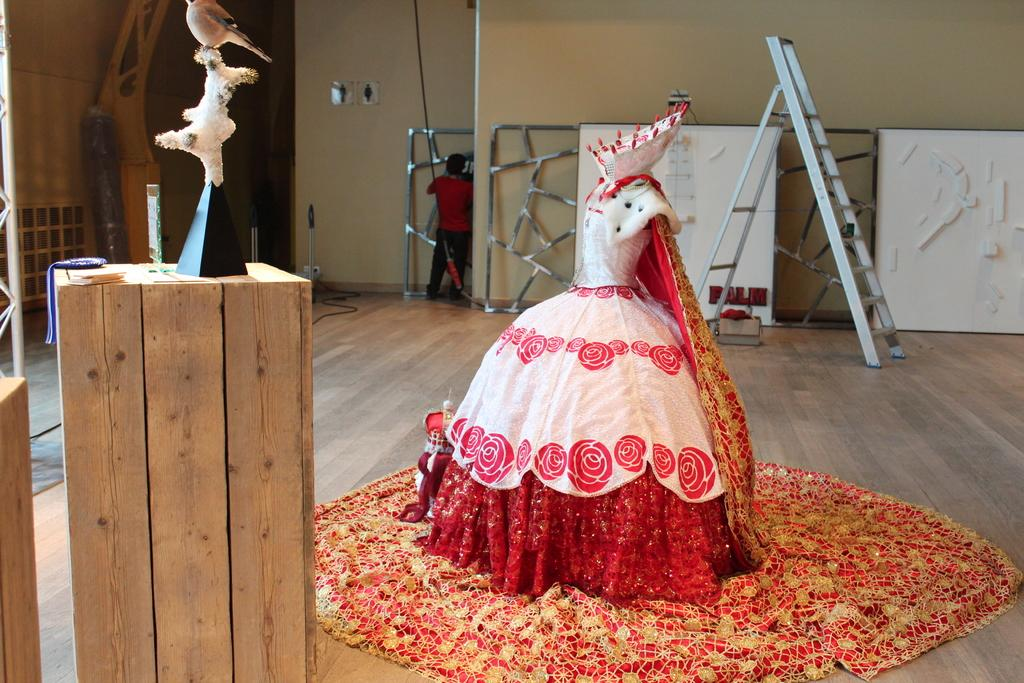What is present in the image that serves as a background? There is a wall in the image that serves as a background. Who or what can be seen in front of the wall? There is a man standing in the image. What object is visible in the image that can be used for climbing? There is a ladder in the image that can be used for climbing. What object is present in the image that can be used for sitting or standing? There is a mat in the image that can be used for sitting or standing. What type of objects are present in the image that are meant for play? There are toys in the image that are meant for play. What type of wood is used to make the island in the image? There is no island present in the image, so it is not possible to determine what type of wood might be used. What grade does the man in the image receive for his performance? There is no indication of a performance or grading system in the image, so it is not possible to determine the man's grade. 